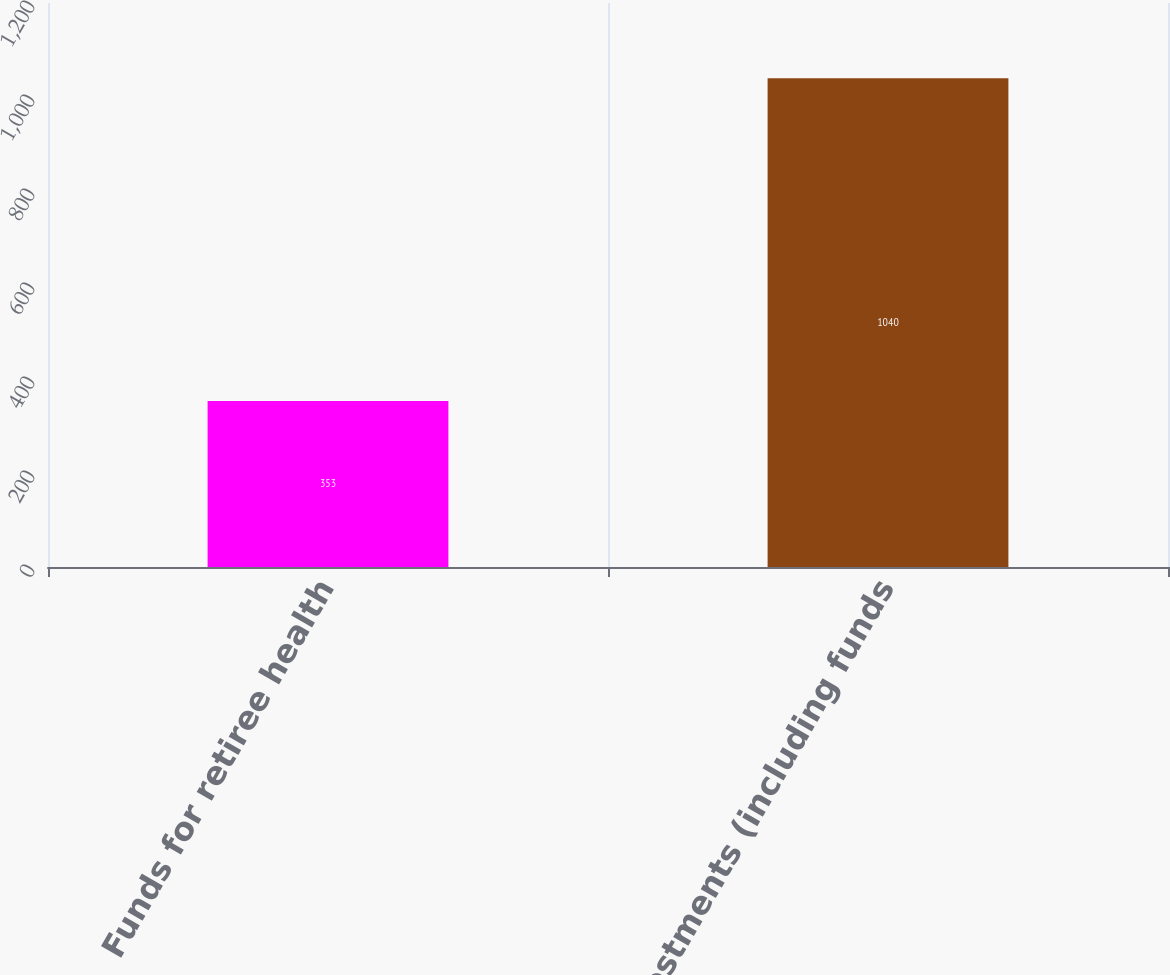Convert chart. <chart><loc_0><loc_0><loc_500><loc_500><bar_chart><fcel>Funds for retiree health<fcel>Investments (including funds<nl><fcel>353<fcel>1040<nl></chart> 